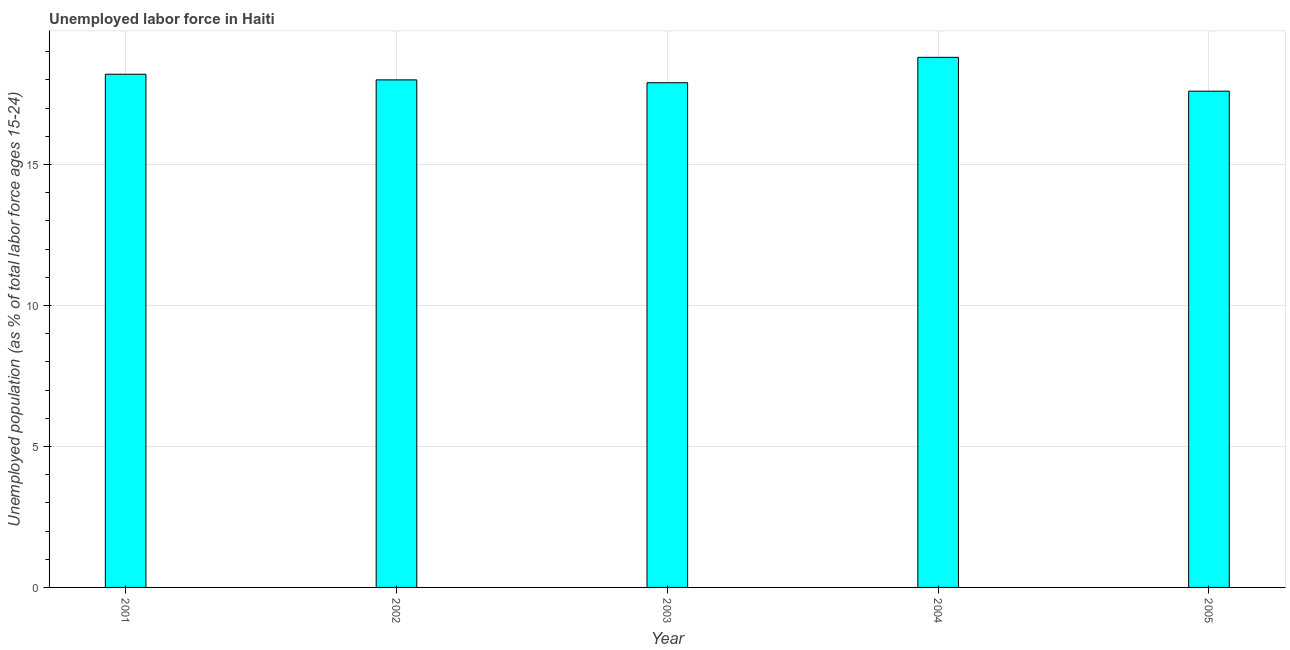What is the title of the graph?
Offer a very short reply. Unemployed labor force in Haiti. What is the label or title of the Y-axis?
Make the answer very short. Unemployed population (as % of total labor force ages 15-24). What is the total unemployed youth population in 2004?
Keep it short and to the point. 18.8. Across all years, what is the maximum total unemployed youth population?
Provide a short and direct response. 18.8. Across all years, what is the minimum total unemployed youth population?
Your answer should be compact. 17.6. In which year was the total unemployed youth population minimum?
Your answer should be compact. 2005. What is the sum of the total unemployed youth population?
Ensure brevity in your answer.  90.5. What is the difference between the total unemployed youth population in 2001 and 2002?
Provide a short and direct response. 0.2. What is the median total unemployed youth population?
Ensure brevity in your answer.  18. In how many years, is the total unemployed youth population greater than 11 %?
Your answer should be very brief. 5. What is the ratio of the total unemployed youth population in 2004 to that in 2005?
Offer a very short reply. 1.07. Is the total unemployed youth population in 2004 less than that in 2005?
Make the answer very short. No. Is the difference between the total unemployed youth population in 2002 and 2004 greater than the difference between any two years?
Your answer should be compact. No. Are all the bars in the graph horizontal?
Offer a terse response. No. What is the difference between two consecutive major ticks on the Y-axis?
Offer a very short reply. 5. Are the values on the major ticks of Y-axis written in scientific E-notation?
Offer a very short reply. No. What is the Unemployed population (as % of total labor force ages 15-24) of 2001?
Keep it short and to the point. 18.2. What is the Unemployed population (as % of total labor force ages 15-24) in 2002?
Your answer should be compact. 18. What is the Unemployed population (as % of total labor force ages 15-24) of 2003?
Your answer should be compact. 17.9. What is the Unemployed population (as % of total labor force ages 15-24) in 2004?
Your response must be concise. 18.8. What is the Unemployed population (as % of total labor force ages 15-24) in 2005?
Provide a short and direct response. 17.6. What is the difference between the Unemployed population (as % of total labor force ages 15-24) in 2001 and 2004?
Your answer should be very brief. -0.6. What is the difference between the Unemployed population (as % of total labor force ages 15-24) in 2001 and 2005?
Give a very brief answer. 0.6. What is the difference between the Unemployed population (as % of total labor force ages 15-24) in 2002 and 2004?
Your answer should be compact. -0.8. What is the difference between the Unemployed population (as % of total labor force ages 15-24) in 2003 and 2004?
Ensure brevity in your answer.  -0.9. What is the difference between the Unemployed population (as % of total labor force ages 15-24) in 2003 and 2005?
Provide a short and direct response. 0.3. What is the difference between the Unemployed population (as % of total labor force ages 15-24) in 2004 and 2005?
Provide a short and direct response. 1.2. What is the ratio of the Unemployed population (as % of total labor force ages 15-24) in 2001 to that in 2004?
Keep it short and to the point. 0.97. What is the ratio of the Unemployed population (as % of total labor force ages 15-24) in 2001 to that in 2005?
Offer a terse response. 1.03. What is the ratio of the Unemployed population (as % of total labor force ages 15-24) in 2002 to that in 2003?
Your response must be concise. 1.01. What is the ratio of the Unemployed population (as % of total labor force ages 15-24) in 2003 to that in 2005?
Provide a succinct answer. 1.02. What is the ratio of the Unemployed population (as % of total labor force ages 15-24) in 2004 to that in 2005?
Give a very brief answer. 1.07. 